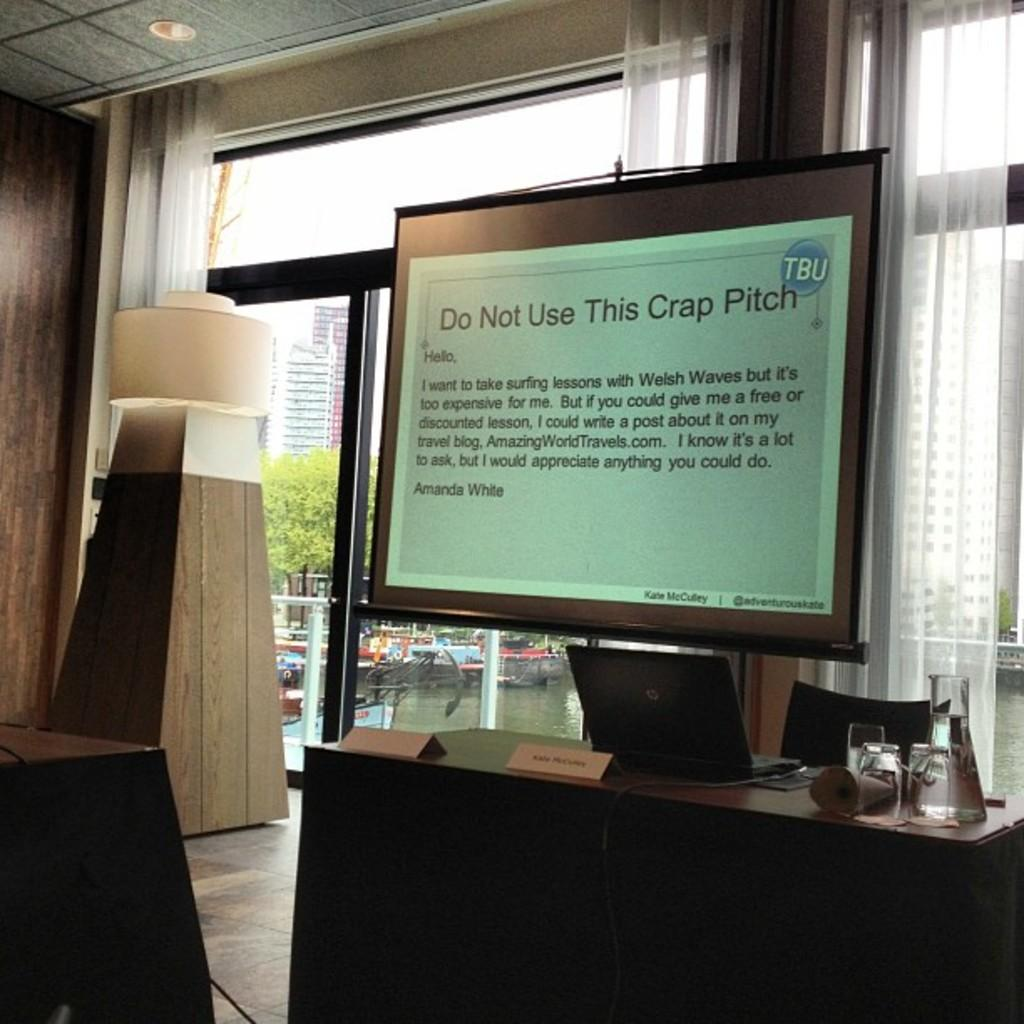What is the main electronic device in the image? There is a laptop in the image. What is the person using the laptop sitting on? There is a chair in the image. What type of containers are present in the image? There are glass tumblers in the image. What is the purpose of the name board in the image? The name board is likely used for identification or labeling purposes. What type of furniture is present in the image? There is a table in the image. What type of structures can be seen in the background of the image? There are skyscrapers in the image. What type of natural elements can be seen in the image? There are trees and water visible in the image. What type of vehicles are present in the image? There are boats in the image. What type of coat is hanging on the wall in the image? There is no coat present in the image. What type of tub is visible in the image? There is no tub present in the image. 